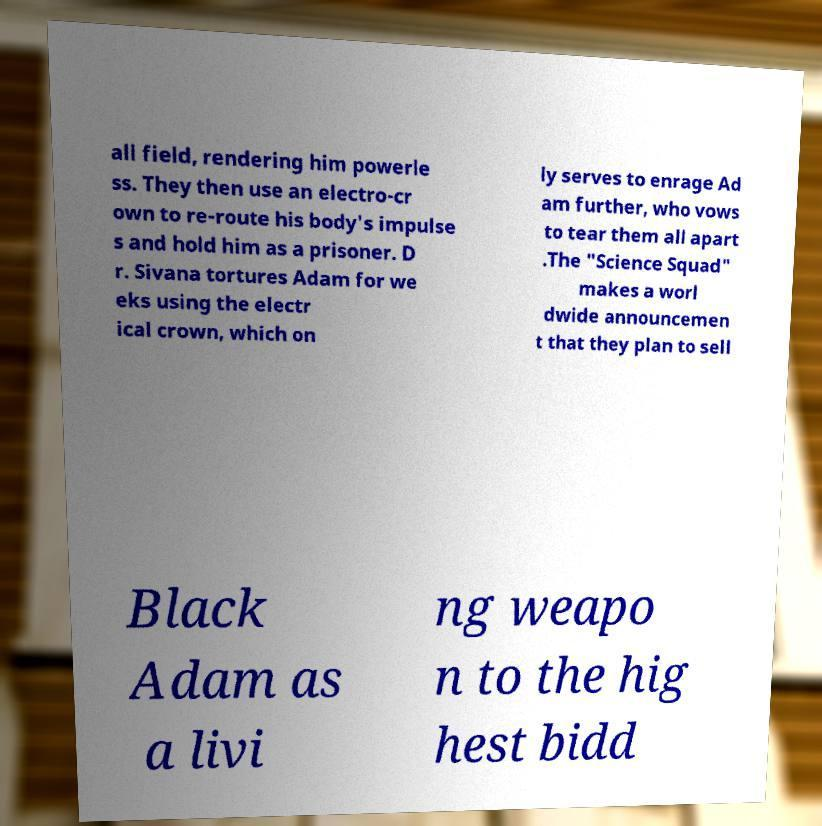For documentation purposes, I need the text within this image transcribed. Could you provide that? all field, rendering him powerle ss. They then use an electro-cr own to re-route his body's impulse s and hold him as a prisoner. D r. Sivana tortures Adam for we eks using the electr ical crown, which on ly serves to enrage Ad am further, who vows to tear them all apart .The "Science Squad" makes a worl dwide announcemen t that they plan to sell Black Adam as a livi ng weapo n to the hig hest bidd 